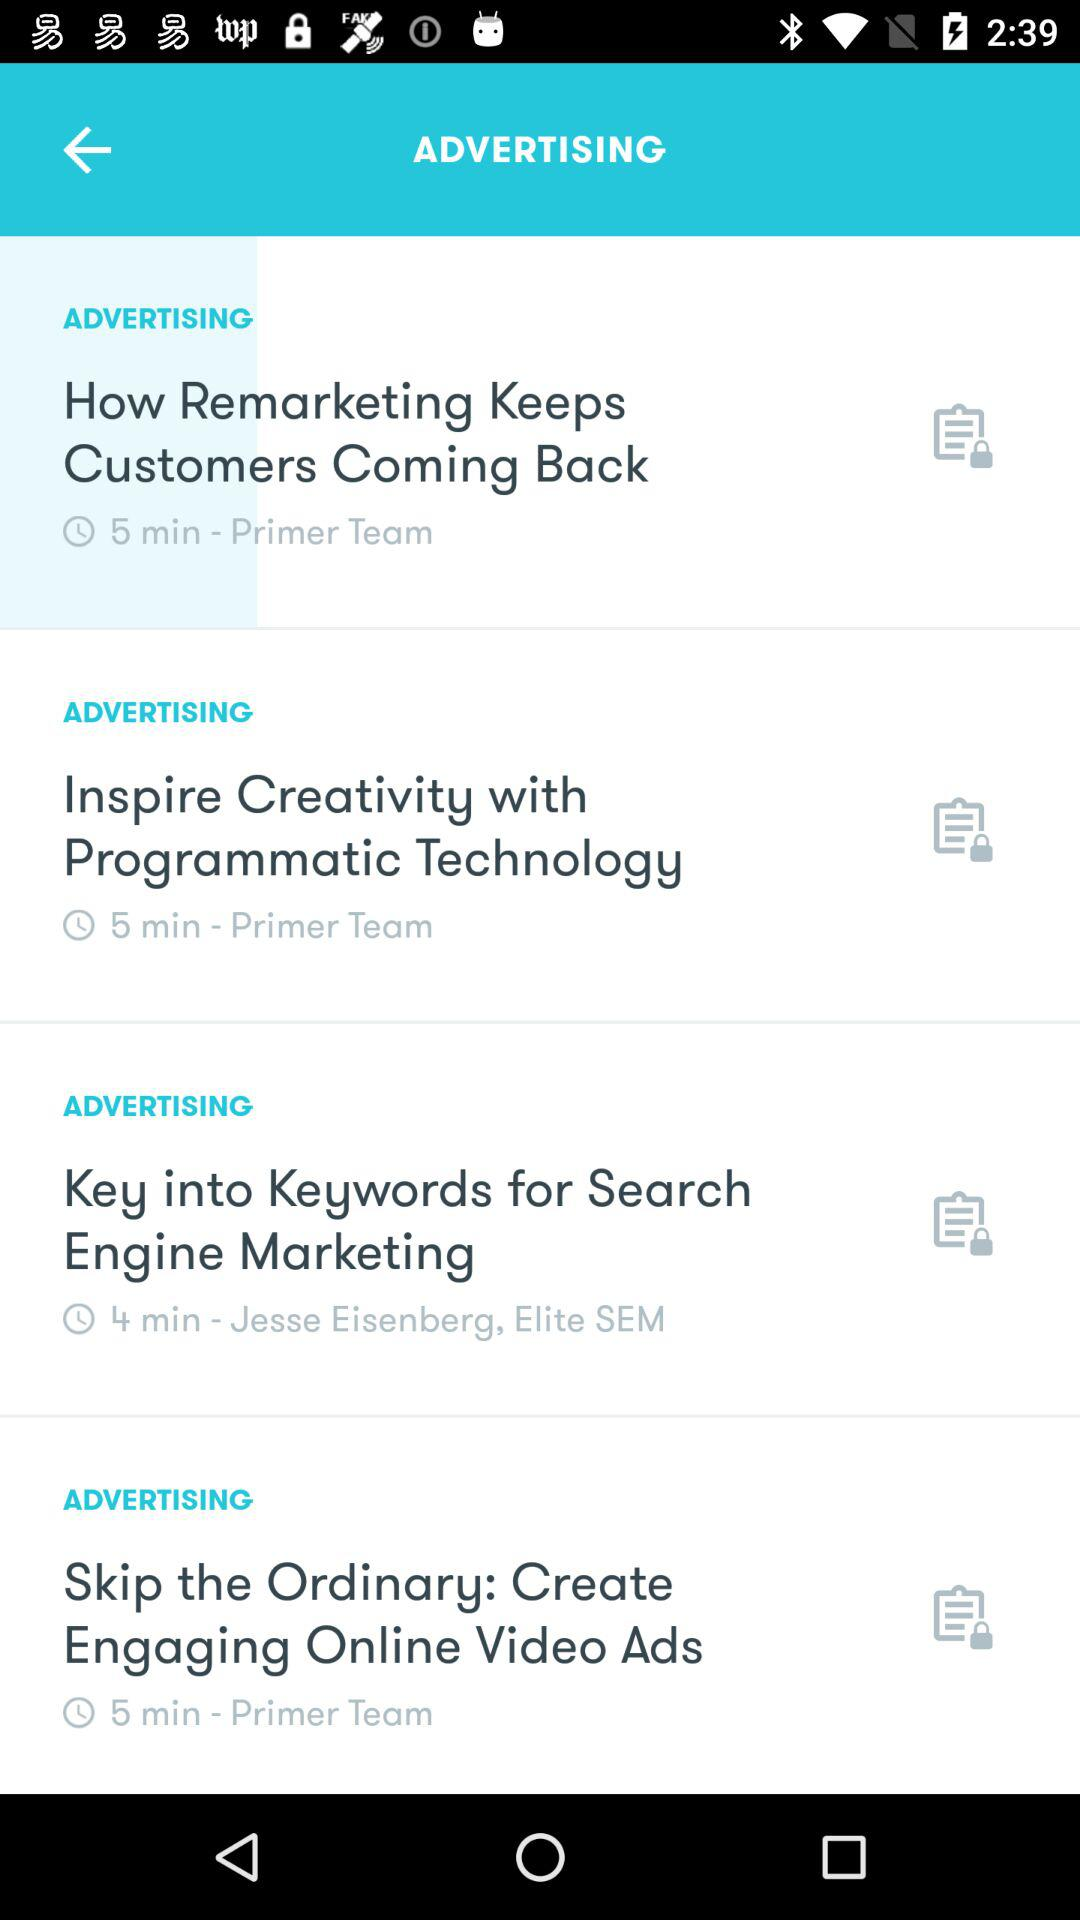How many videos are there in total?
Answer the question using a single word or phrase. 4 